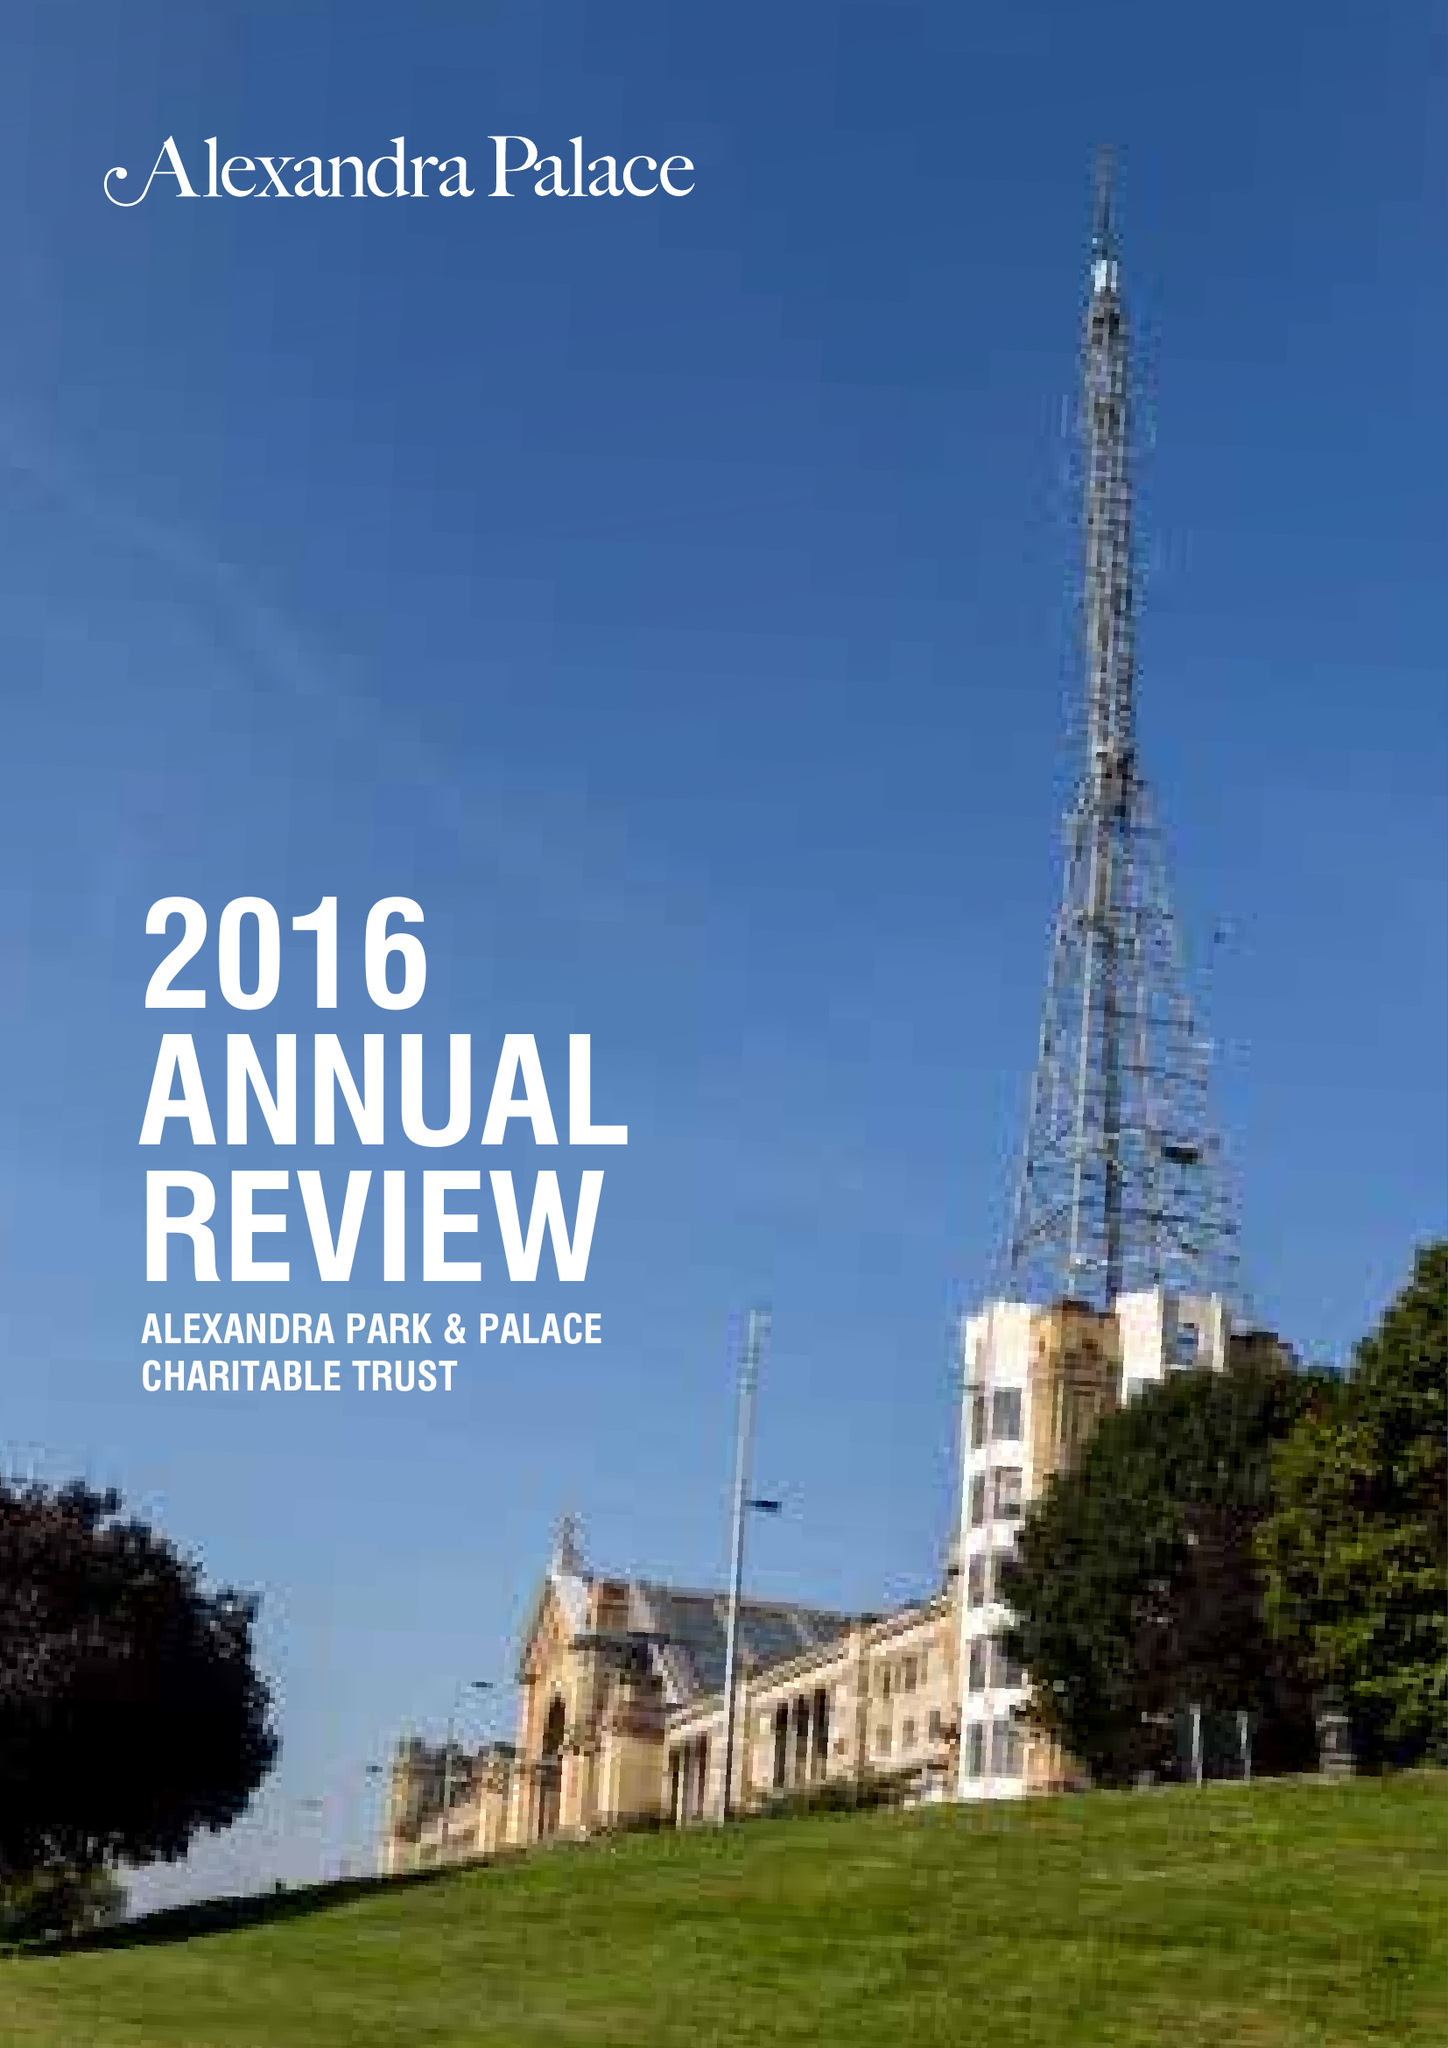What is the value for the address__postcode?
Answer the question using a single word or phrase. N22 7AY 